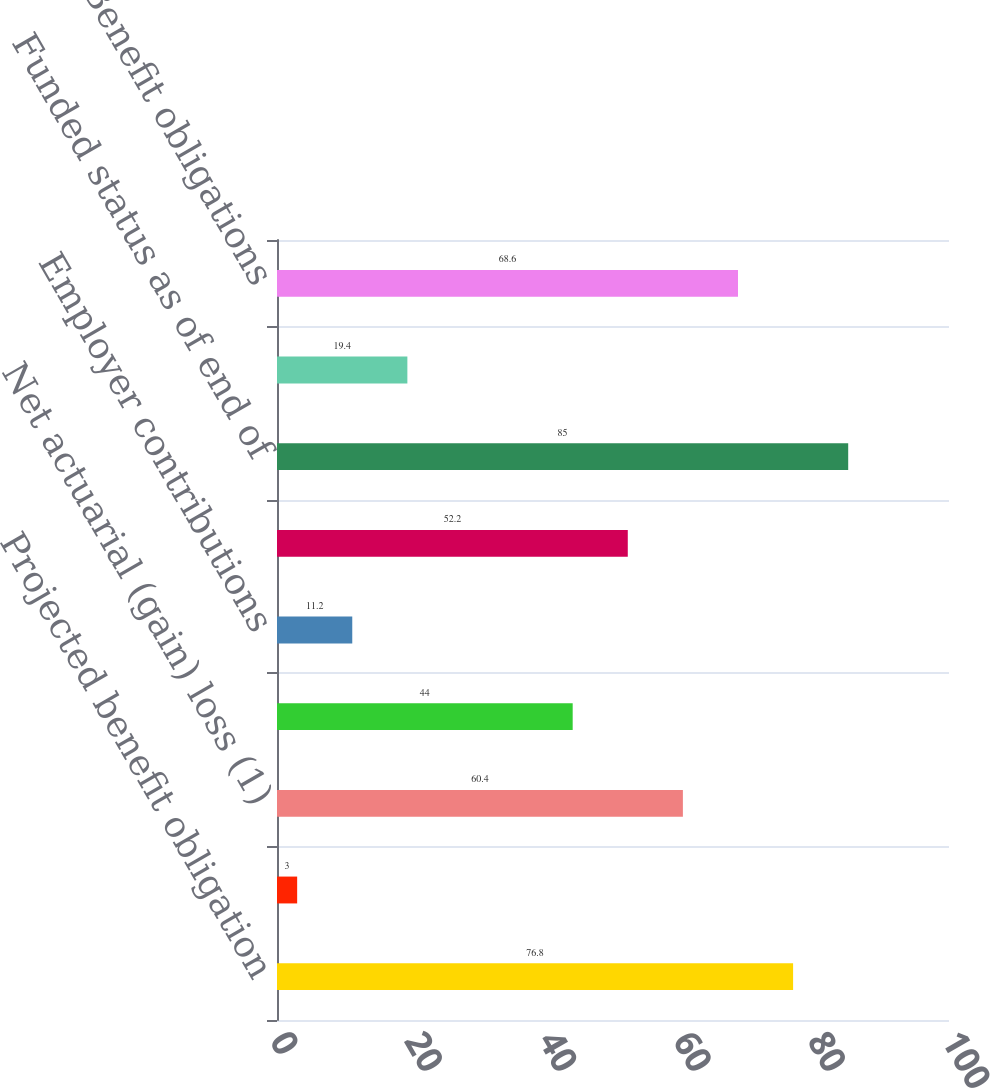Convert chart to OTSL. <chart><loc_0><loc_0><loc_500><loc_500><bar_chart><fcel>Projected benefit obligation<fcel>Interest cost<fcel>Net actuarial (gain) loss (1)<fcel>Benefits paid<fcel>Employer contributions<fcel>Benefits paid (2)<fcel>Funded status as of end of<fcel>Current Other liabilities<fcel>Benefit obligations<nl><fcel>76.8<fcel>3<fcel>60.4<fcel>44<fcel>11.2<fcel>52.2<fcel>85<fcel>19.4<fcel>68.6<nl></chart> 